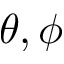Convert formula to latex. <formula><loc_0><loc_0><loc_500><loc_500>\theta , \phi</formula> 